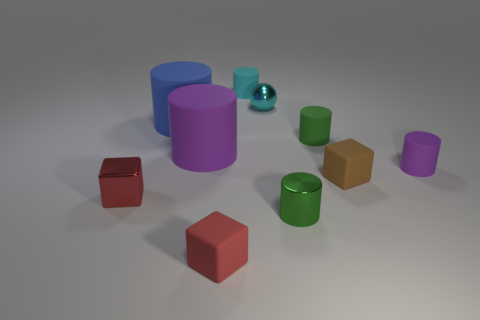Subtract all big rubber cylinders. How many cylinders are left? 4 Subtract 1 cubes. How many cubes are left? 2 Subtract all blue cylinders. How many cylinders are left? 5 Subtract all blue cylinders. How many cyan blocks are left? 0 Subtract all red balls. Subtract all green cubes. How many balls are left? 1 Subtract all tiny cubes. Subtract all large matte cylinders. How many objects are left? 5 Add 2 green shiny things. How many green shiny things are left? 3 Add 9 big red cylinders. How many big red cylinders exist? 9 Subtract 1 green cylinders. How many objects are left? 9 Subtract all balls. How many objects are left? 9 